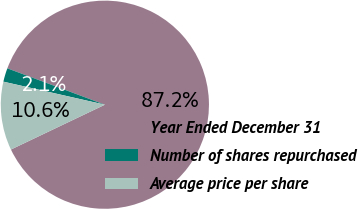<chart> <loc_0><loc_0><loc_500><loc_500><pie_chart><fcel>Year Ended December 31<fcel>Number of shares repurchased<fcel>Average price per share<nl><fcel>87.24%<fcel>2.13%<fcel>10.64%<nl></chart> 